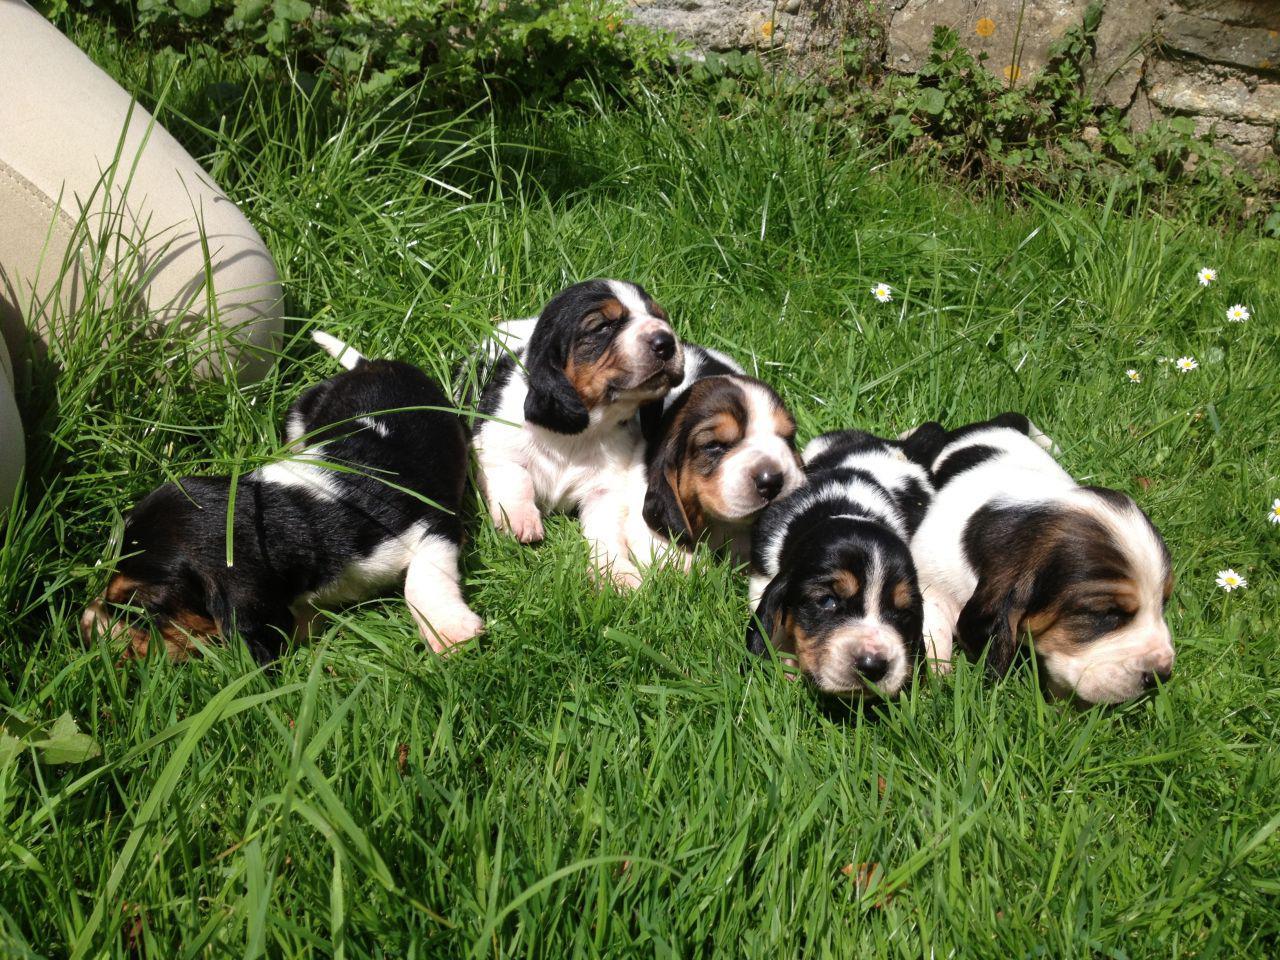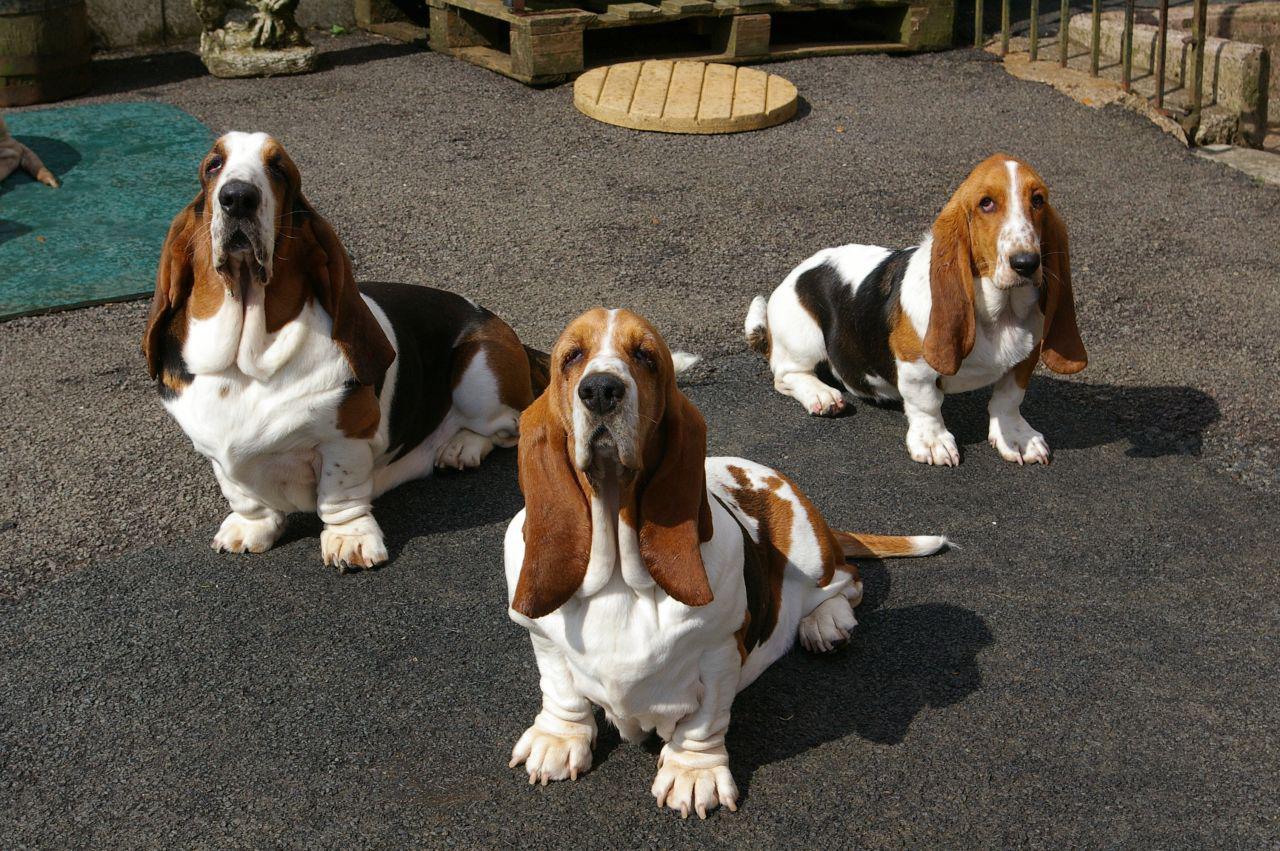The first image is the image on the left, the second image is the image on the right. Examine the images to the left and right. Is the description "Right image shows exactly three basset hounds." accurate? Answer yes or no. Yes. 